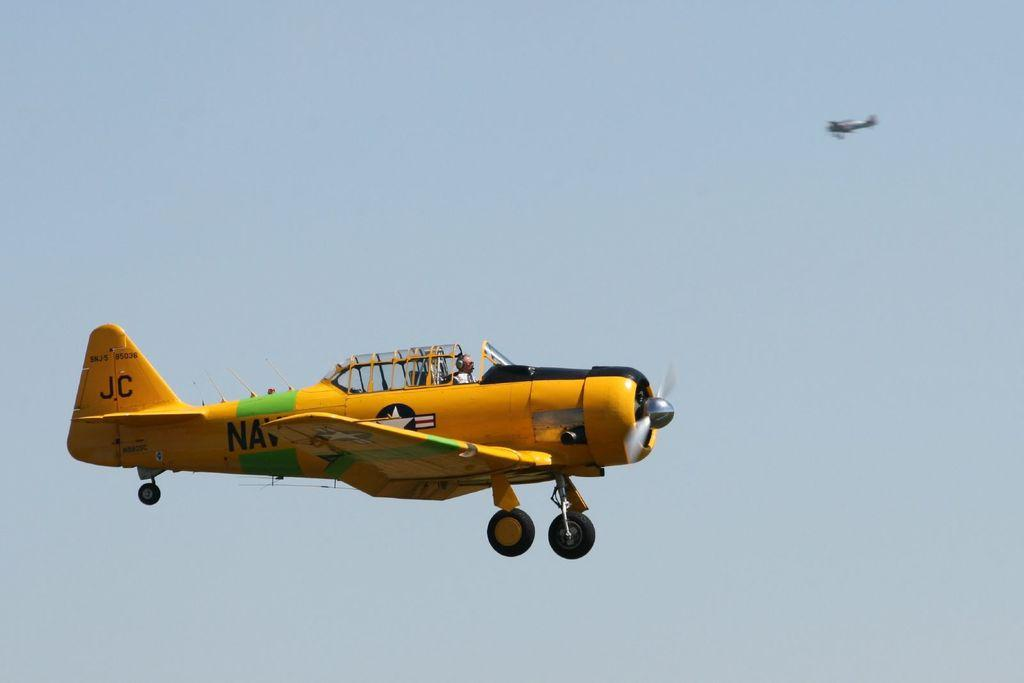Provide a one-sentence caption for the provided image. A man flies a yellow plain with JC painted on the rear rudder. 